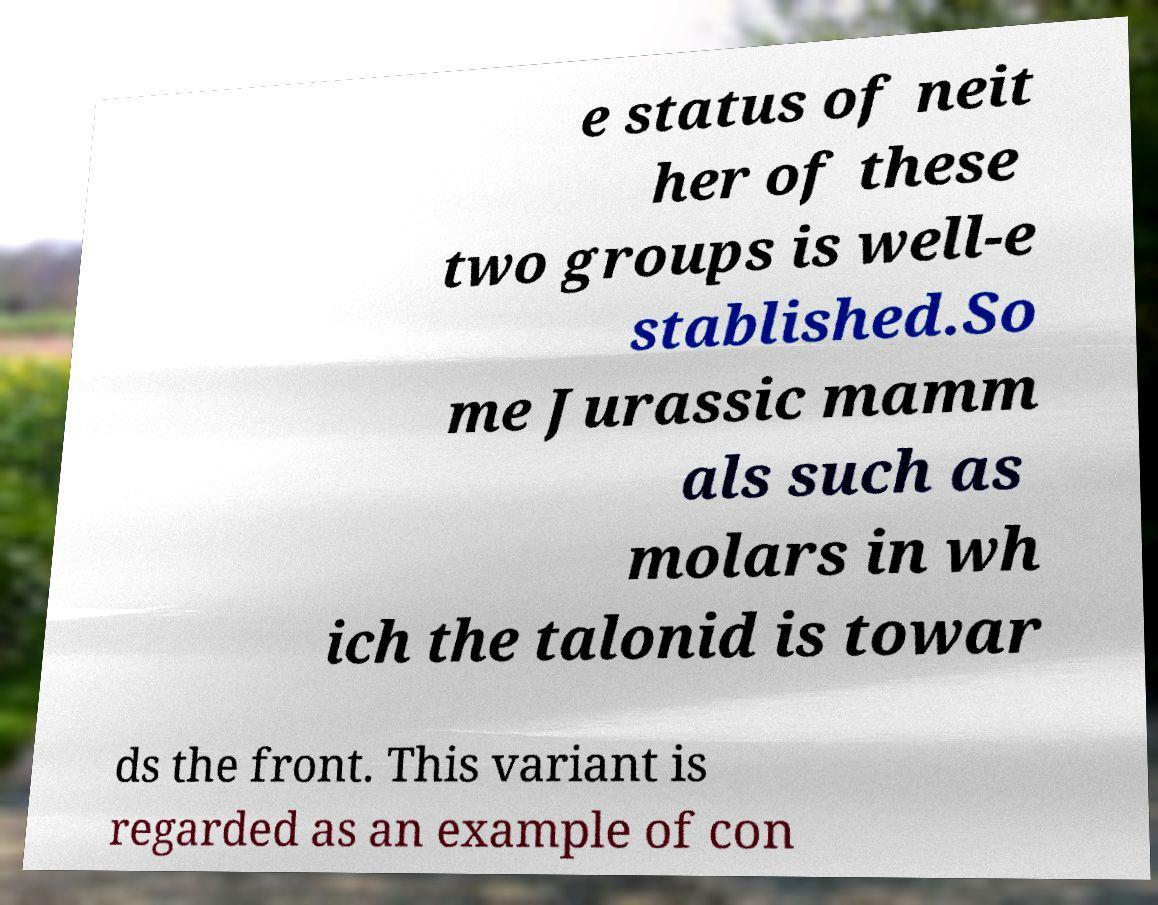Can you read and provide the text displayed in the image?This photo seems to have some interesting text. Can you extract and type it out for me? e status of neit her of these two groups is well-e stablished.So me Jurassic mamm als such as molars in wh ich the talonid is towar ds the front. This variant is regarded as an example of con 